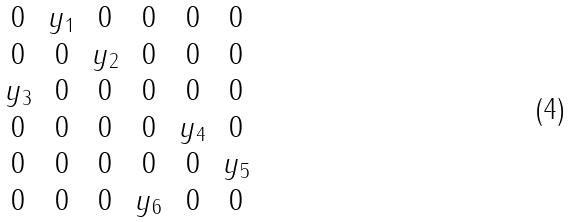Convert formula to latex. <formula><loc_0><loc_0><loc_500><loc_500>\begin{matrix} 0 & y _ { 1 } & 0 & 0 & 0 & 0 \\ 0 & 0 & y _ { 2 } & 0 & 0 & 0 \\ y _ { 3 } & 0 & 0 & 0 & 0 & 0 \\ 0 & 0 & 0 & 0 & y _ { 4 } & 0 \\ 0 & 0 & 0 & 0 & 0 & y _ { 5 } \\ 0 & 0 & 0 & y _ { 6 } & 0 & 0 \end{matrix}</formula> 